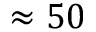Convert formula to latex. <formula><loc_0><loc_0><loc_500><loc_500>\approx 5 0</formula> 